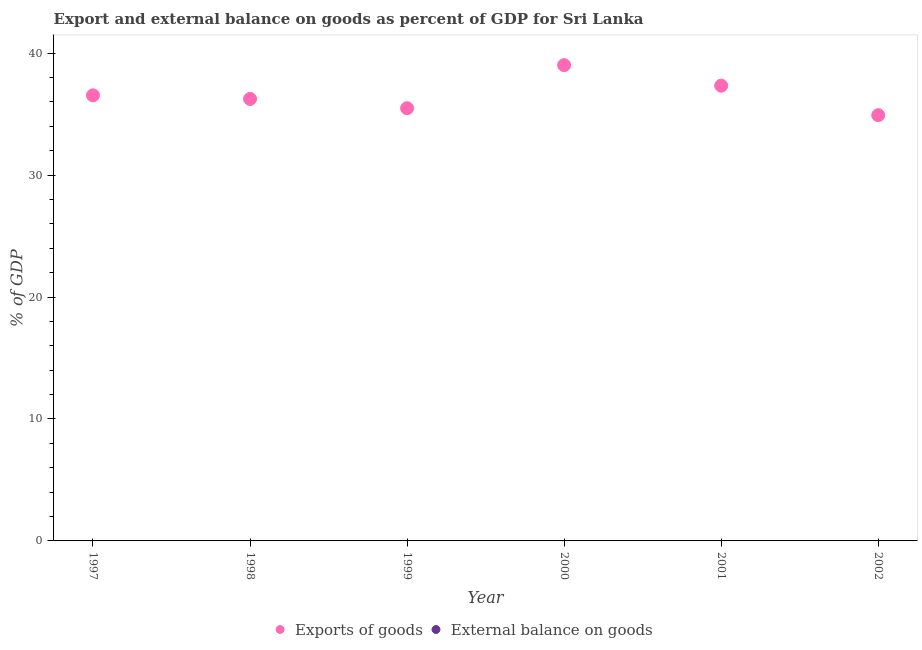What is the export of goods as percentage of gdp in 2001?
Offer a very short reply. 37.33. Across all years, what is the maximum export of goods as percentage of gdp?
Your response must be concise. 39.02. Across all years, what is the minimum external balance on goods as percentage of gdp?
Offer a terse response. 0. What is the total external balance on goods as percentage of gdp in the graph?
Offer a terse response. 0. What is the difference between the export of goods as percentage of gdp in 1997 and that in 1998?
Keep it short and to the point. 0.29. What is the difference between the external balance on goods as percentage of gdp in 1997 and the export of goods as percentage of gdp in 2002?
Your answer should be very brief. -34.91. What is the ratio of the export of goods as percentage of gdp in 2000 to that in 2002?
Keep it short and to the point. 1.12. What is the difference between the highest and the second highest export of goods as percentage of gdp?
Give a very brief answer. 1.68. What is the difference between the highest and the lowest export of goods as percentage of gdp?
Give a very brief answer. 4.1. In how many years, is the export of goods as percentage of gdp greater than the average export of goods as percentage of gdp taken over all years?
Keep it short and to the point. 2. Does the export of goods as percentage of gdp monotonically increase over the years?
Make the answer very short. No. Is the export of goods as percentage of gdp strictly less than the external balance on goods as percentage of gdp over the years?
Make the answer very short. No. How many dotlines are there?
Offer a terse response. 1. What is the difference between two consecutive major ticks on the Y-axis?
Your answer should be compact. 10. Does the graph contain any zero values?
Give a very brief answer. Yes. Does the graph contain grids?
Provide a short and direct response. No. How many legend labels are there?
Offer a very short reply. 2. How are the legend labels stacked?
Provide a short and direct response. Horizontal. What is the title of the graph?
Offer a very short reply. Export and external balance on goods as percent of GDP for Sri Lanka. Does "Secondary school" appear as one of the legend labels in the graph?
Offer a terse response. No. What is the label or title of the Y-axis?
Your answer should be compact. % of GDP. What is the % of GDP in Exports of goods in 1997?
Offer a very short reply. 36.54. What is the % of GDP of External balance on goods in 1997?
Ensure brevity in your answer.  0. What is the % of GDP in Exports of goods in 1998?
Keep it short and to the point. 36.24. What is the % of GDP in Exports of goods in 1999?
Your response must be concise. 35.48. What is the % of GDP in Exports of goods in 2000?
Make the answer very short. 39.02. What is the % of GDP in Exports of goods in 2001?
Your answer should be compact. 37.33. What is the % of GDP in Exports of goods in 2002?
Your answer should be compact. 34.91. Across all years, what is the maximum % of GDP in Exports of goods?
Your answer should be very brief. 39.02. Across all years, what is the minimum % of GDP in Exports of goods?
Give a very brief answer. 34.91. What is the total % of GDP in Exports of goods in the graph?
Provide a succinct answer. 219.53. What is the difference between the % of GDP in Exports of goods in 1997 and that in 1998?
Your answer should be compact. 0.29. What is the difference between the % of GDP of Exports of goods in 1997 and that in 1999?
Your answer should be compact. 1.05. What is the difference between the % of GDP in Exports of goods in 1997 and that in 2000?
Provide a short and direct response. -2.48. What is the difference between the % of GDP of Exports of goods in 1997 and that in 2001?
Keep it short and to the point. -0.79. What is the difference between the % of GDP of Exports of goods in 1997 and that in 2002?
Your answer should be very brief. 1.62. What is the difference between the % of GDP of Exports of goods in 1998 and that in 1999?
Provide a succinct answer. 0.76. What is the difference between the % of GDP of Exports of goods in 1998 and that in 2000?
Offer a very short reply. -2.77. What is the difference between the % of GDP in Exports of goods in 1998 and that in 2001?
Your answer should be very brief. -1.09. What is the difference between the % of GDP of Exports of goods in 1998 and that in 2002?
Make the answer very short. 1.33. What is the difference between the % of GDP in Exports of goods in 1999 and that in 2000?
Provide a short and direct response. -3.53. What is the difference between the % of GDP of Exports of goods in 1999 and that in 2001?
Offer a terse response. -1.85. What is the difference between the % of GDP of Exports of goods in 1999 and that in 2002?
Give a very brief answer. 0.57. What is the difference between the % of GDP in Exports of goods in 2000 and that in 2001?
Ensure brevity in your answer.  1.68. What is the difference between the % of GDP of Exports of goods in 2000 and that in 2002?
Your answer should be compact. 4.1. What is the difference between the % of GDP of Exports of goods in 2001 and that in 2002?
Offer a very short reply. 2.42. What is the average % of GDP of Exports of goods per year?
Offer a very short reply. 36.59. What is the average % of GDP of External balance on goods per year?
Provide a succinct answer. 0. What is the ratio of the % of GDP in Exports of goods in 1997 to that in 1998?
Ensure brevity in your answer.  1.01. What is the ratio of the % of GDP of Exports of goods in 1997 to that in 1999?
Make the answer very short. 1.03. What is the ratio of the % of GDP of Exports of goods in 1997 to that in 2000?
Offer a very short reply. 0.94. What is the ratio of the % of GDP in Exports of goods in 1997 to that in 2001?
Make the answer very short. 0.98. What is the ratio of the % of GDP in Exports of goods in 1997 to that in 2002?
Offer a terse response. 1.05. What is the ratio of the % of GDP of Exports of goods in 1998 to that in 1999?
Your answer should be compact. 1.02. What is the ratio of the % of GDP in Exports of goods in 1998 to that in 2000?
Offer a terse response. 0.93. What is the ratio of the % of GDP in Exports of goods in 1998 to that in 2001?
Provide a short and direct response. 0.97. What is the ratio of the % of GDP in Exports of goods in 1998 to that in 2002?
Ensure brevity in your answer.  1.04. What is the ratio of the % of GDP of Exports of goods in 1999 to that in 2000?
Provide a short and direct response. 0.91. What is the ratio of the % of GDP in Exports of goods in 1999 to that in 2001?
Your answer should be very brief. 0.95. What is the ratio of the % of GDP in Exports of goods in 1999 to that in 2002?
Your response must be concise. 1.02. What is the ratio of the % of GDP in Exports of goods in 2000 to that in 2001?
Your answer should be compact. 1.05. What is the ratio of the % of GDP in Exports of goods in 2000 to that in 2002?
Keep it short and to the point. 1.12. What is the ratio of the % of GDP in Exports of goods in 2001 to that in 2002?
Ensure brevity in your answer.  1.07. What is the difference between the highest and the second highest % of GDP in Exports of goods?
Provide a short and direct response. 1.68. What is the difference between the highest and the lowest % of GDP in Exports of goods?
Your answer should be compact. 4.1. 